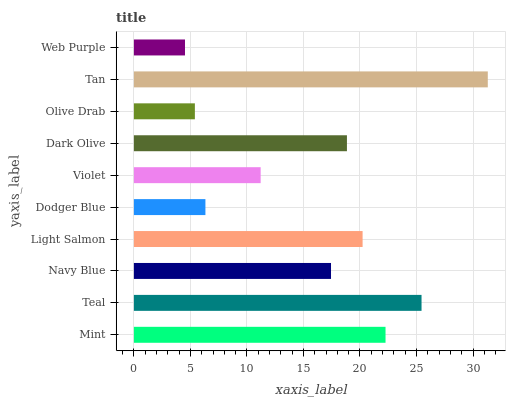Is Web Purple the minimum?
Answer yes or no. Yes. Is Tan the maximum?
Answer yes or no. Yes. Is Teal the minimum?
Answer yes or no. No. Is Teal the maximum?
Answer yes or no. No. Is Teal greater than Mint?
Answer yes or no. Yes. Is Mint less than Teal?
Answer yes or no. Yes. Is Mint greater than Teal?
Answer yes or no. No. Is Teal less than Mint?
Answer yes or no. No. Is Dark Olive the high median?
Answer yes or no. Yes. Is Navy Blue the low median?
Answer yes or no. Yes. Is Tan the high median?
Answer yes or no. No. Is Violet the low median?
Answer yes or no. No. 